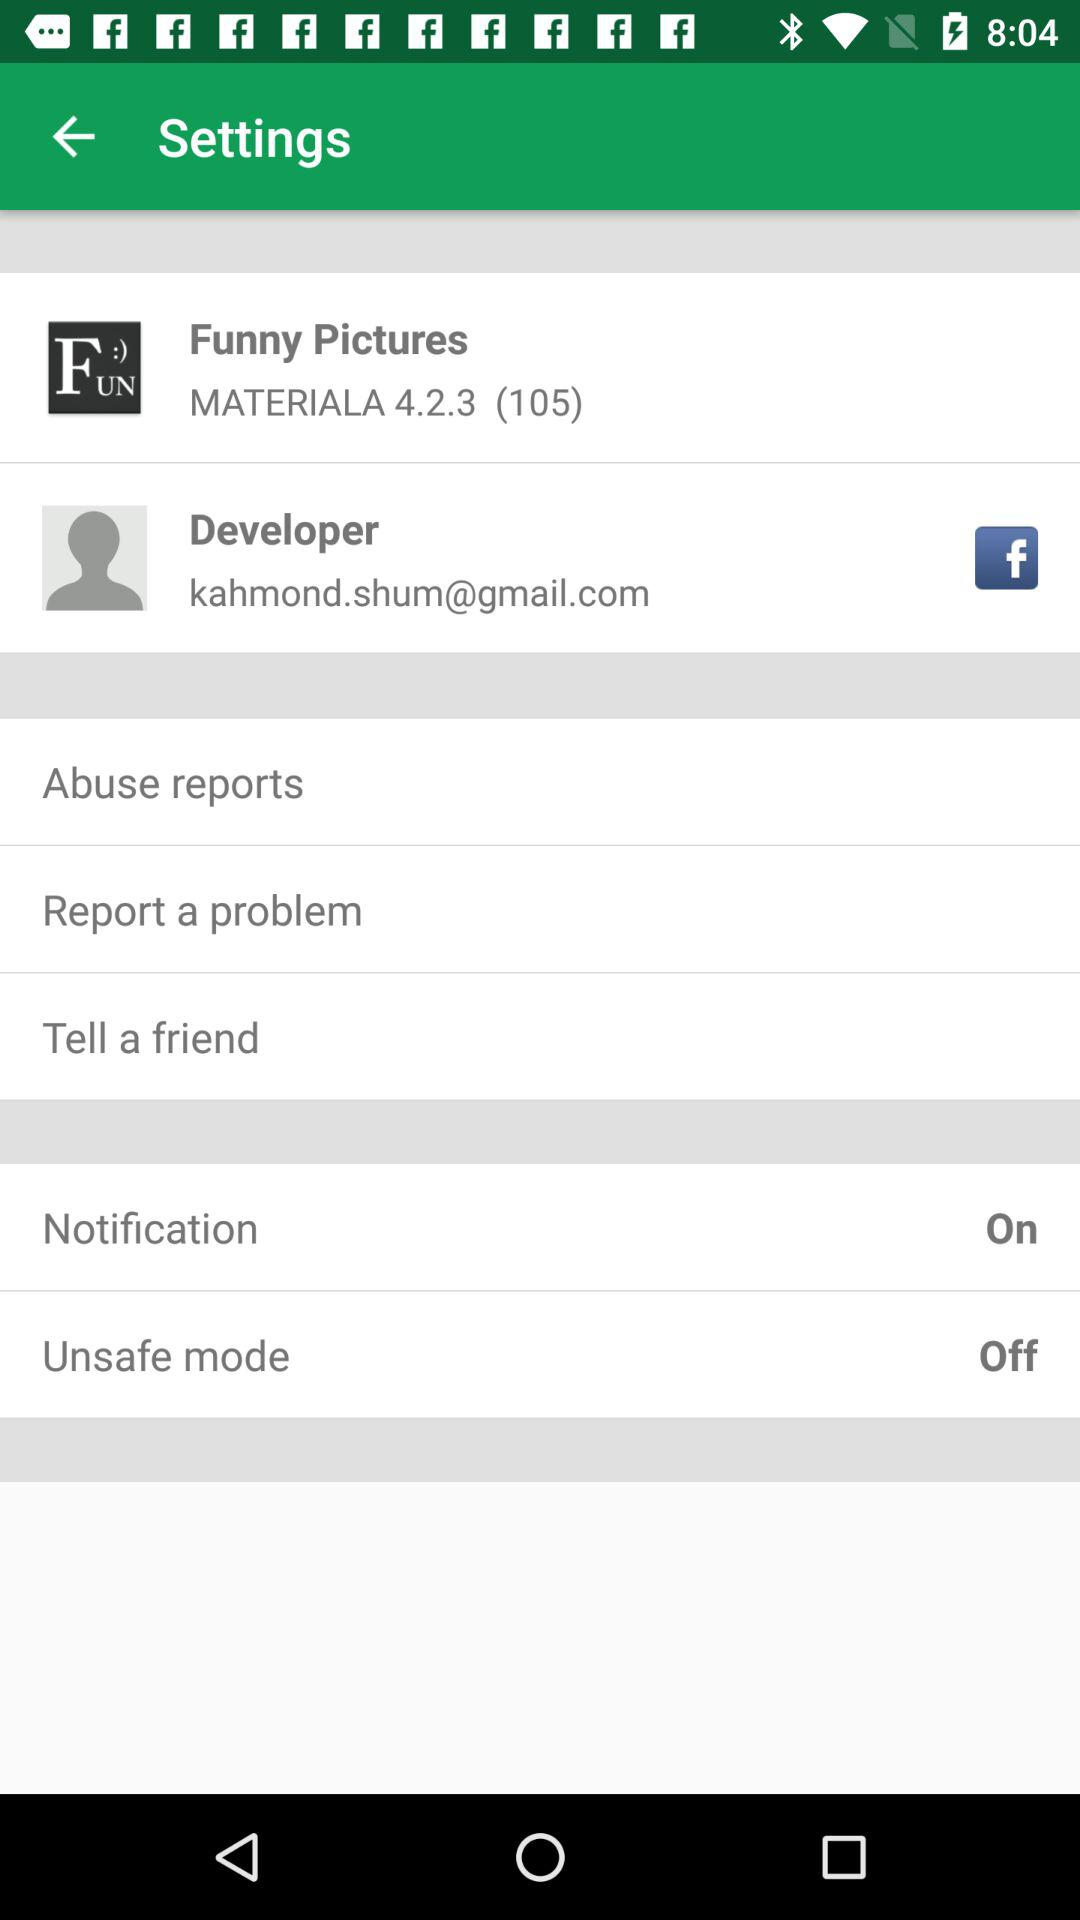What is the application name that is used to sign up with the email address? The application name is "Facebook". 